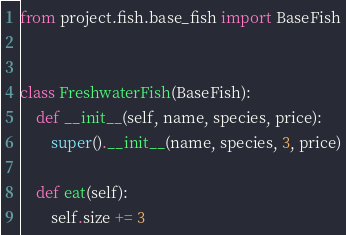Convert code to text. <code><loc_0><loc_0><loc_500><loc_500><_Python_>from project.fish.base_fish import BaseFish


class FreshwaterFish(BaseFish):
    def __init__(self, name, species, price):
        super().__init__(name, species, 3, price)

    def eat(self):
        self.size += 3

</code> 